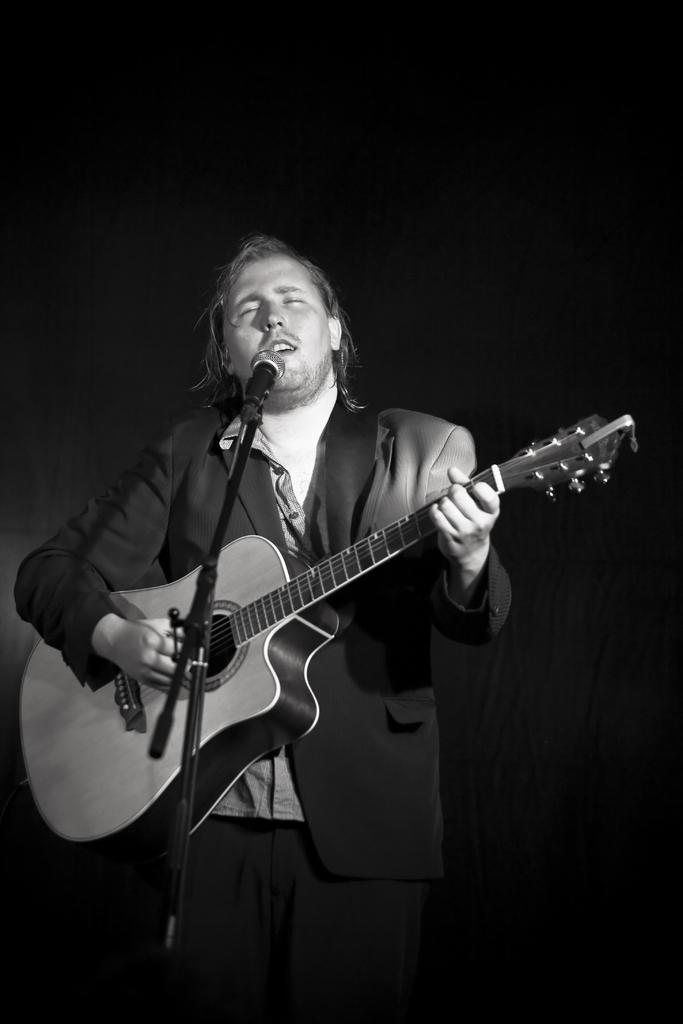Who is the main subject in the image? There is a man in the image. What is the man doing in the image? The man is standing, playing a guitar, and singing. What object is present in the image that is typically used for amplifying sound? There is a microphone in the image. Can you see a squirrel playing with a station in the image? No, there is no squirrel or station present in the image. What type of pleasure does the man derive from playing the guitar in the image? The image does not provide information about the man's emotions or feelings, so we cannot determine the type of pleasure he derives from playing the guitar. 